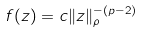<formula> <loc_0><loc_0><loc_500><loc_500>f ( z ) = c \| z \| _ { \rho } ^ { - ( p - 2 ) }</formula> 